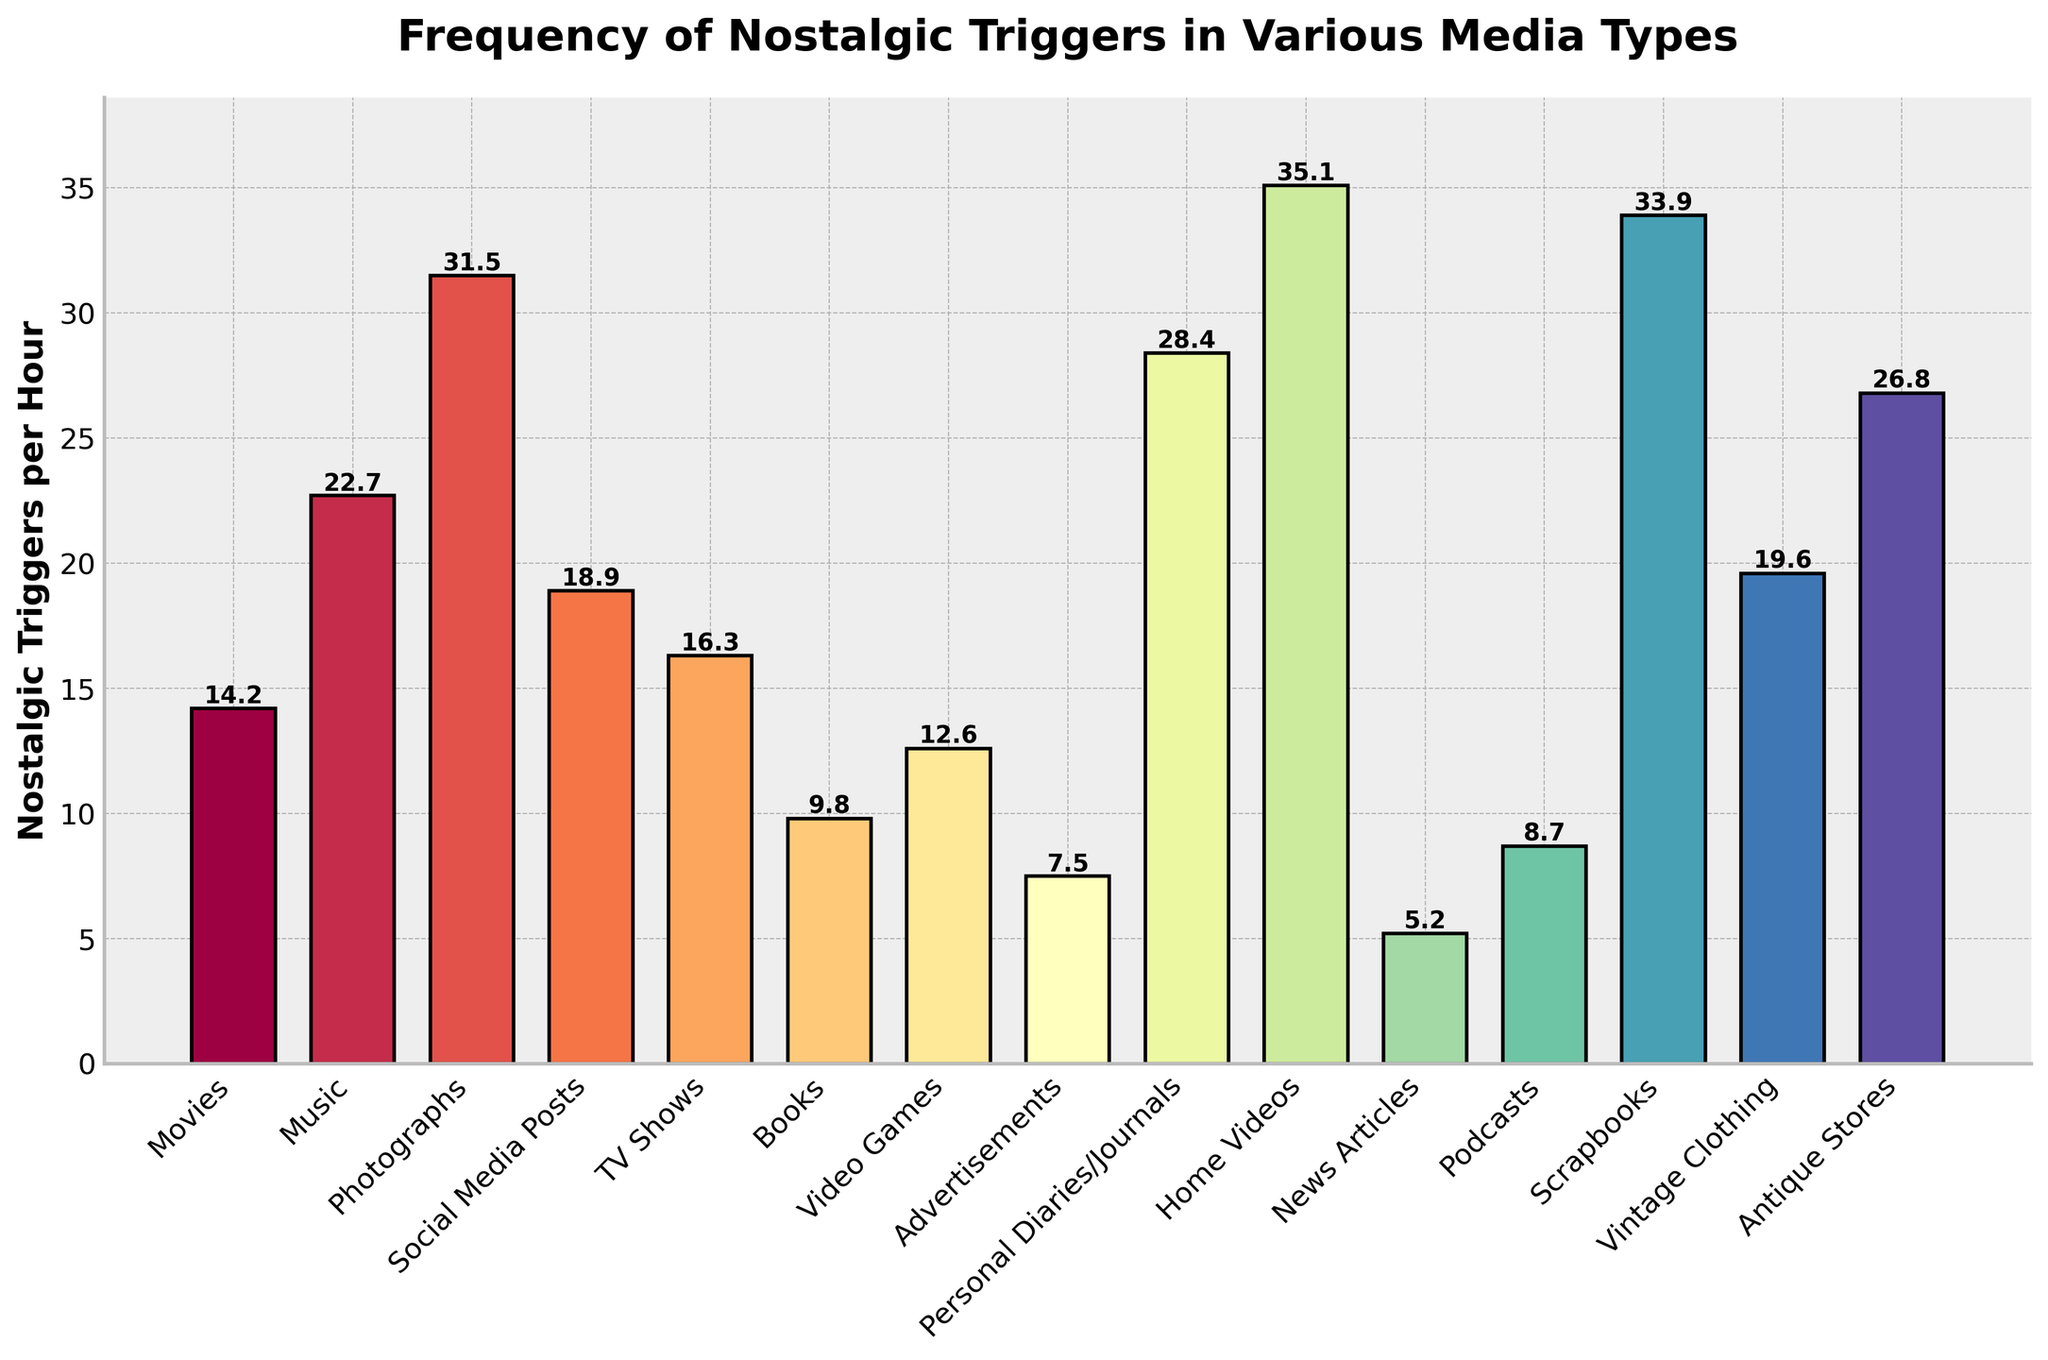Which media type has the highest frequency of nostalgic triggers per hour? To determine this, look at the bar that reaches the highest point on the y-axis. In this case, the tallest bar represents 'Home Videos'.
Answer: Home Videos Which media type has the least frequency of nostalgic triggers per hour? Look for the shortest bar in the plot. Here, the shortest bar corresponds to 'News Articles'.
Answer: News Articles How much higher is the frequency of nostalgic triggers in "Photographs" compared to "Books"? Find the height of the bars corresponding to 'Photographs' and 'Books'. Subtract the value for 'Books' from the value for 'Photographs' (31.5 - 9.8).
Answer: 21.7 What is the combined frequency of nostalgic triggers for "Movies" and "TV Shows"? Locate the bars for 'Movies' and 'TV Shows', then add their heights together (14.2 + 16.3).
Answer: 30.5 Which media type has a higher frequency of nostalgic triggers per hour, "Video Games" or "Podcasts"? Compare the heights of the bars for 'Video Games' and 'Podcasts'. The bar for 'Video Games' is taller.
Answer: Video Games Is the frequency of nostalgic triggers per hour for "Social Media Posts" greater than that for "Vintage Clothing"? Compare the heights of the bars for 'Social Media Posts' and 'Vintage Clothing'. The bar for 'Social Media Posts' is shorter.
Answer: No What is the range of the frequency of nostalgic triggers among the media types shown? The range is obtained by subtracting the smallest value from the largest value. The smallest value is 'News Articles' (5.2) and the largest is 'Home Videos' (35.1). So, 35.1 - 5.2.
Answer: 29.9 What is the average frequency of nostalgic triggers per hour for "Advertisements," "Podcasts," and "Books"? Add the frequencies for 'Advertisements', 'Podcasts', and 'Books', then divide by 3 ((7.5 + 8.7 + 9.8)/3).
Answer: 8.7 Which has a higher frequency of nostalgic triggers per hour, the average of "Home Videos," "Photographs," and "Scrapbooks," or "Music"? First, find the average of 'Home Videos', 'Photographs', and 'Scrapbooks' ((35.1 + 31.5 + 33.9)/3 ≈ 33.5). Compare this to the frequency of 'Music' (22.7).
Answer: Average of Home Videos, Photographs, and Scrapbooks 